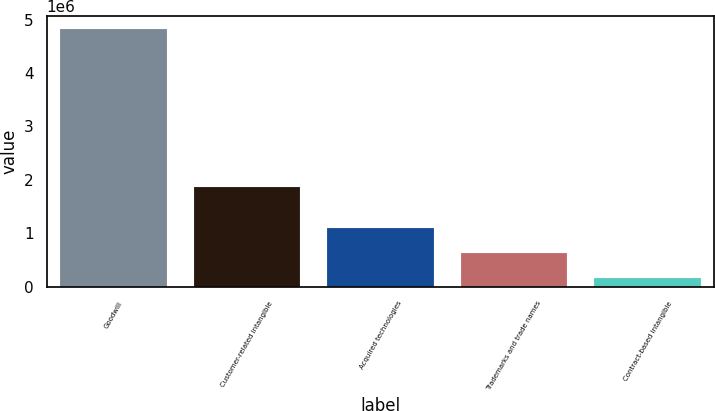<chart> <loc_0><loc_0><loc_500><loc_500><bar_chart><fcel>Goodwill<fcel>Customer-related intangible<fcel>Acquired technologies<fcel>Trademarks and trade names<fcel>Contract-based intangible<nl><fcel>4.8294e+06<fcel>1.86471e+06<fcel>1.09379e+06<fcel>626842<fcel>159890<nl></chart> 